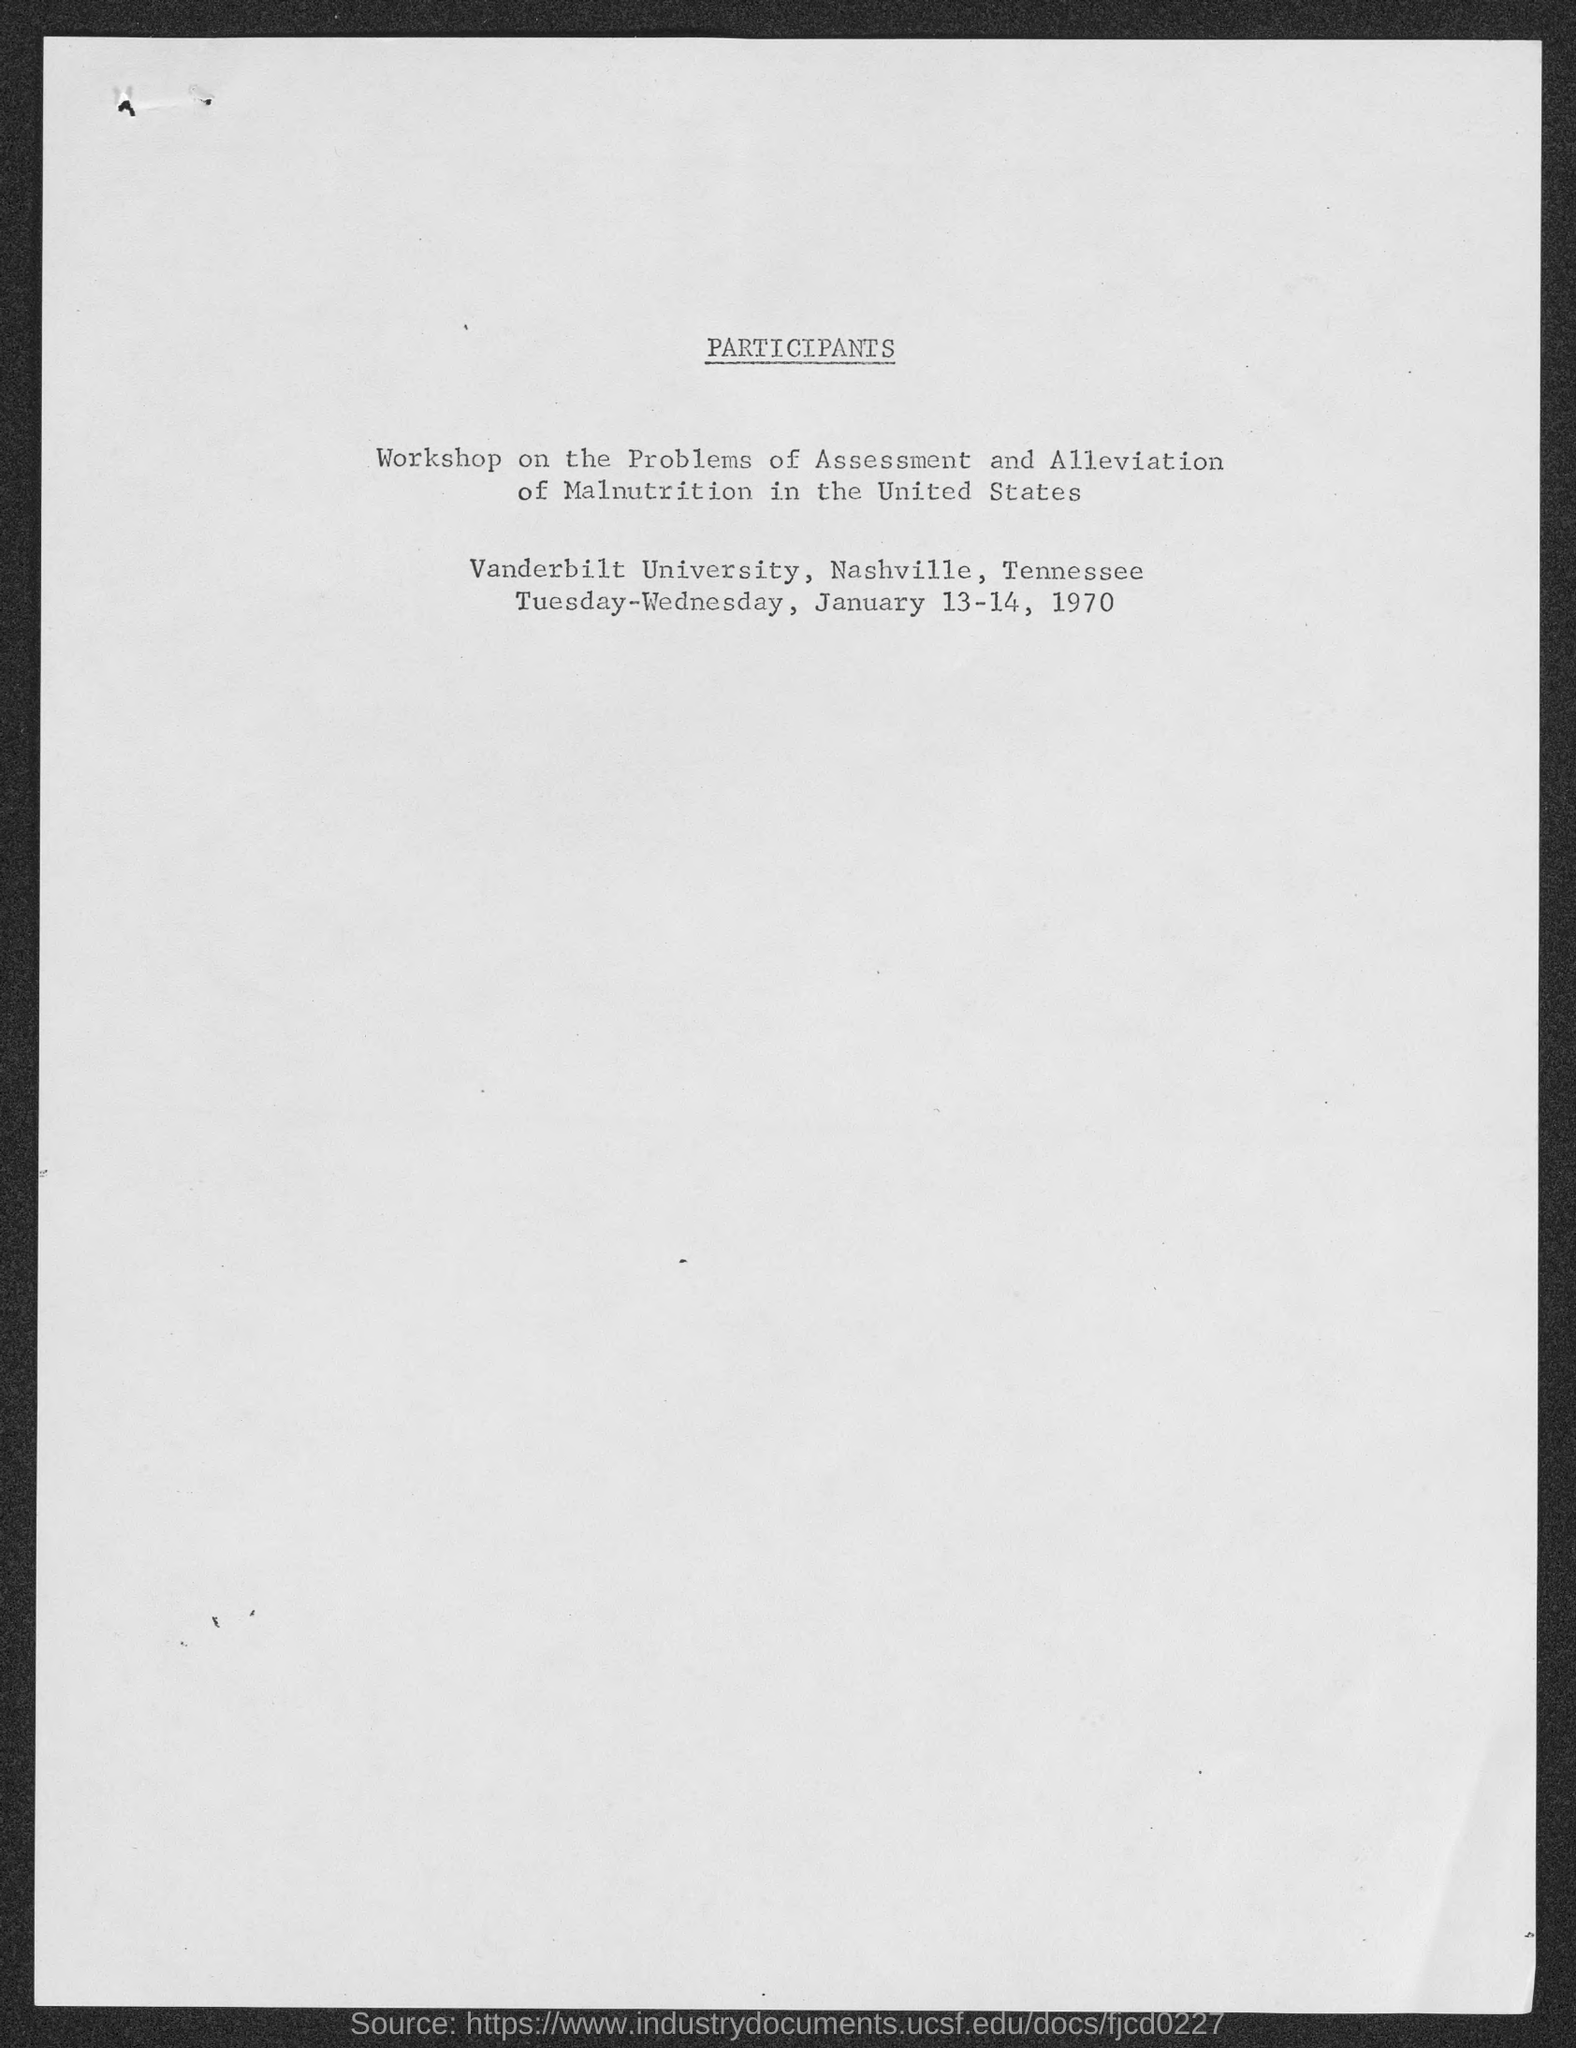Where is the Workshop on the problems of Assessment and Alleviation of Malnutrition in the United States held?
Give a very brief answer. Vanderbilt University, Nashville, Tennessee. 